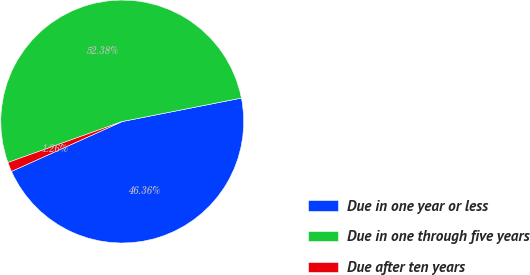Convert chart. <chart><loc_0><loc_0><loc_500><loc_500><pie_chart><fcel>Due in one year or less<fcel>Due in one through five years<fcel>Due after ten years<nl><fcel>46.36%<fcel>52.38%<fcel>1.26%<nl></chart> 